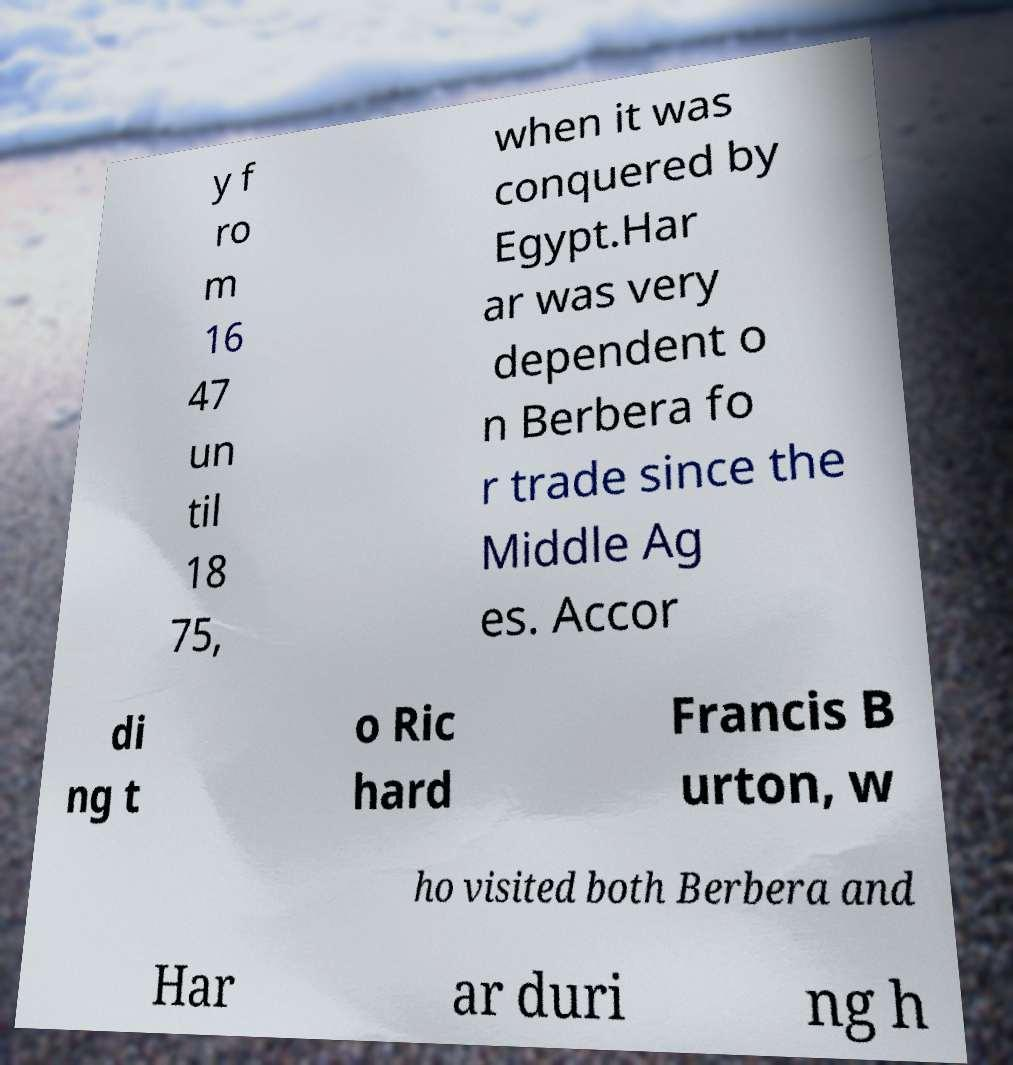Please identify and transcribe the text found in this image. y f ro m 16 47 un til 18 75, when it was conquered by Egypt.Har ar was very dependent o n Berbera fo r trade since the Middle Ag es. Accor di ng t o Ric hard Francis B urton, w ho visited both Berbera and Har ar duri ng h 